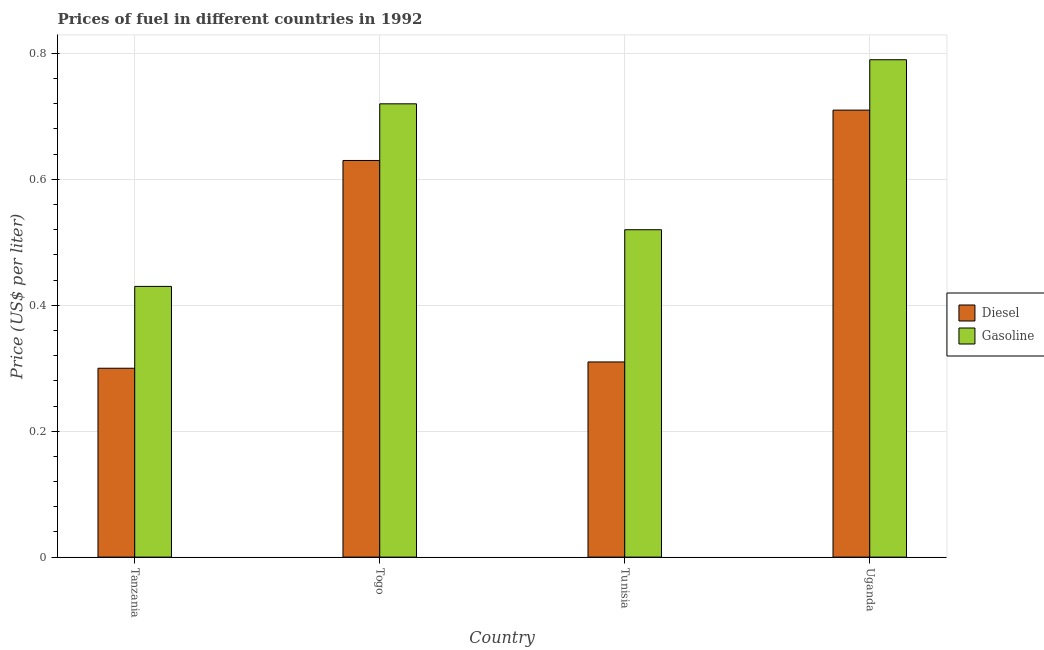How many bars are there on the 1st tick from the left?
Provide a succinct answer. 2. How many bars are there on the 1st tick from the right?
Give a very brief answer. 2. What is the label of the 1st group of bars from the left?
Offer a very short reply. Tanzania. In how many cases, is the number of bars for a given country not equal to the number of legend labels?
Ensure brevity in your answer.  0. What is the diesel price in Uganda?
Make the answer very short. 0.71. Across all countries, what is the maximum gasoline price?
Give a very brief answer. 0.79. Across all countries, what is the minimum diesel price?
Your answer should be compact. 0.3. In which country was the diesel price maximum?
Offer a terse response. Uganda. In which country was the diesel price minimum?
Your answer should be compact. Tanzania. What is the total diesel price in the graph?
Your answer should be very brief. 1.95. What is the difference between the diesel price in Togo and that in Tunisia?
Keep it short and to the point. 0.32. What is the difference between the gasoline price in Uganda and the diesel price in Tanzania?
Give a very brief answer. 0.49. What is the average gasoline price per country?
Provide a succinct answer. 0.61. What is the difference between the diesel price and gasoline price in Tanzania?
Your answer should be very brief. -0.13. In how many countries, is the gasoline price greater than 0.7200000000000001 US$ per litre?
Ensure brevity in your answer.  1. What is the ratio of the diesel price in Tunisia to that in Uganda?
Give a very brief answer. 0.44. What is the difference between the highest and the second highest diesel price?
Offer a terse response. 0.08. What is the difference between the highest and the lowest diesel price?
Provide a short and direct response. 0.41. What does the 2nd bar from the left in Uganda represents?
Your answer should be compact. Gasoline. What does the 1st bar from the right in Uganda represents?
Give a very brief answer. Gasoline. Are all the bars in the graph horizontal?
Give a very brief answer. No. Does the graph contain any zero values?
Make the answer very short. No. Does the graph contain grids?
Provide a succinct answer. Yes. Where does the legend appear in the graph?
Offer a terse response. Center right. What is the title of the graph?
Your answer should be very brief. Prices of fuel in different countries in 1992. Does "Central government" appear as one of the legend labels in the graph?
Give a very brief answer. No. What is the label or title of the Y-axis?
Your response must be concise. Price (US$ per liter). What is the Price (US$ per liter) of Gasoline in Tanzania?
Ensure brevity in your answer.  0.43. What is the Price (US$ per liter) in Diesel in Togo?
Provide a succinct answer. 0.63. What is the Price (US$ per liter) of Gasoline in Togo?
Offer a terse response. 0.72. What is the Price (US$ per liter) in Diesel in Tunisia?
Make the answer very short. 0.31. What is the Price (US$ per liter) of Gasoline in Tunisia?
Keep it short and to the point. 0.52. What is the Price (US$ per liter) in Diesel in Uganda?
Give a very brief answer. 0.71. What is the Price (US$ per liter) of Gasoline in Uganda?
Give a very brief answer. 0.79. Across all countries, what is the maximum Price (US$ per liter) of Diesel?
Your response must be concise. 0.71. Across all countries, what is the maximum Price (US$ per liter) of Gasoline?
Keep it short and to the point. 0.79. Across all countries, what is the minimum Price (US$ per liter) of Gasoline?
Provide a short and direct response. 0.43. What is the total Price (US$ per liter) of Diesel in the graph?
Your answer should be very brief. 1.95. What is the total Price (US$ per liter) in Gasoline in the graph?
Give a very brief answer. 2.46. What is the difference between the Price (US$ per liter) in Diesel in Tanzania and that in Togo?
Provide a short and direct response. -0.33. What is the difference between the Price (US$ per liter) in Gasoline in Tanzania and that in Togo?
Make the answer very short. -0.29. What is the difference between the Price (US$ per liter) in Diesel in Tanzania and that in Tunisia?
Make the answer very short. -0.01. What is the difference between the Price (US$ per liter) in Gasoline in Tanzania and that in Tunisia?
Make the answer very short. -0.09. What is the difference between the Price (US$ per liter) of Diesel in Tanzania and that in Uganda?
Your answer should be very brief. -0.41. What is the difference between the Price (US$ per liter) of Gasoline in Tanzania and that in Uganda?
Your response must be concise. -0.36. What is the difference between the Price (US$ per liter) in Diesel in Togo and that in Tunisia?
Offer a terse response. 0.32. What is the difference between the Price (US$ per liter) of Gasoline in Togo and that in Tunisia?
Your answer should be compact. 0.2. What is the difference between the Price (US$ per liter) of Diesel in Togo and that in Uganda?
Give a very brief answer. -0.08. What is the difference between the Price (US$ per liter) of Gasoline in Togo and that in Uganda?
Ensure brevity in your answer.  -0.07. What is the difference between the Price (US$ per liter) of Diesel in Tunisia and that in Uganda?
Provide a short and direct response. -0.4. What is the difference between the Price (US$ per liter) in Gasoline in Tunisia and that in Uganda?
Ensure brevity in your answer.  -0.27. What is the difference between the Price (US$ per liter) of Diesel in Tanzania and the Price (US$ per liter) of Gasoline in Togo?
Your answer should be very brief. -0.42. What is the difference between the Price (US$ per liter) in Diesel in Tanzania and the Price (US$ per liter) in Gasoline in Tunisia?
Offer a terse response. -0.22. What is the difference between the Price (US$ per liter) of Diesel in Tanzania and the Price (US$ per liter) of Gasoline in Uganda?
Your response must be concise. -0.49. What is the difference between the Price (US$ per liter) in Diesel in Togo and the Price (US$ per liter) in Gasoline in Tunisia?
Provide a succinct answer. 0.11. What is the difference between the Price (US$ per liter) of Diesel in Togo and the Price (US$ per liter) of Gasoline in Uganda?
Your answer should be very brief. -0.16. What is the difference between the Price (US$ per liter) in Diesel in Tunisia and the Price (US$ per liter) in Gasoline in Uganda?
Your answer should be compact. -0.48. What is the average Price (US$ per liter) in Diesel per country?
Your answer should be very brief. 0.49. What is the average Price (US$ per liter) of Gasoline per country?
Your answer should be compact. 0.61. What is the difference between the Price (US$ per liter) in Diesel and Price (US$ per liter) in Gasoline in Tanzania?
Your response must be concise. -0.13. What is the difference between the Price (US$ per liter) in Diesel and Price (US$ per liter) in Gasoline in Togo?
Give a very brief answer. -0.09. What is the difference between the Price (US$ per liter) of Diesel and Price (US$ per liter) of Gasoline in Tunisia?
Your response must be concise. -0.21. What is the difference between the Price (US$ per liter) in Diesel and Price (US$ per liter) in Gasoline in Uganda?
Provide a short and direct response. -0.08. What is the ratio of the Price (US$ per liter) in Diesel in Tanzania to that in Togo?
Your answer should be compact. 0.48. What is the ratio of the Price (US$ per liter) of Gasoline in Tanzania to that in Togo?
Keep it short and to the point. 0.6. What is the ratio of the Price (US$ per liter) of Diesel in Tanzania to that in Tunisia?
Your answer should be compact. 0.97. What is the ratio of the Price (US$ per liter) of Gasoline in Tanzania to that in Tunisia?
Offer a very short reply. 0.83. What is the ratio of the Price (US$ per liter) in Diesel in Tanzania to that in Uganda?
Make the answer very short. 0.42. What is the ratio of the Price (US$ per liter) of Gasoline in Tanzania to that in Uganda?
Offer a very short reply. 0.54. What is the ratio of the Price (US$ per liter) of Diesel in Togo to that in Tunisia?
Provide a short and direct response. 2.03. What is the ratio of the Price (US$ per liter) in Gasoline in Togo to that in Tunisia?
Make the answer very short. 1.38. What is the ratio of the Price (US$ per liter) of Diesel in Togo to that in Uganda?
Your answer should be very brief. 0.89. What is the ratio of the Price (US$ per liter) in Gasoline in Togo to that in Uganda?
Provide a short and direct response. 0.91. What is the ratio of the Price (US$ per liter) of Diesel in Tunisia to that in Uganda?
Your answer should be very brief. 0.44. What is the ratio of the Price (US$ per liter) in Gasoline in Tunisia to that in Uganda?
Offer a very short reply. 0.66. What is the difference between the highest and the second highest Price (US$ per liter) in Diesel?
Ensure brevity in your answer.  0.08. What is the difference between the highest and the second highest Price (US$ per liter) of Gasoline?
Make the answer very short. 0.07. What is the difference between the highest and the lowest Price (US$ per liter) of Diesel?
Offer a very short reply. 0.41. What is the difference between the highest and the lowest Price (US$ per liter) in Gasoline?
Your answer should be very brief. 0.36. 